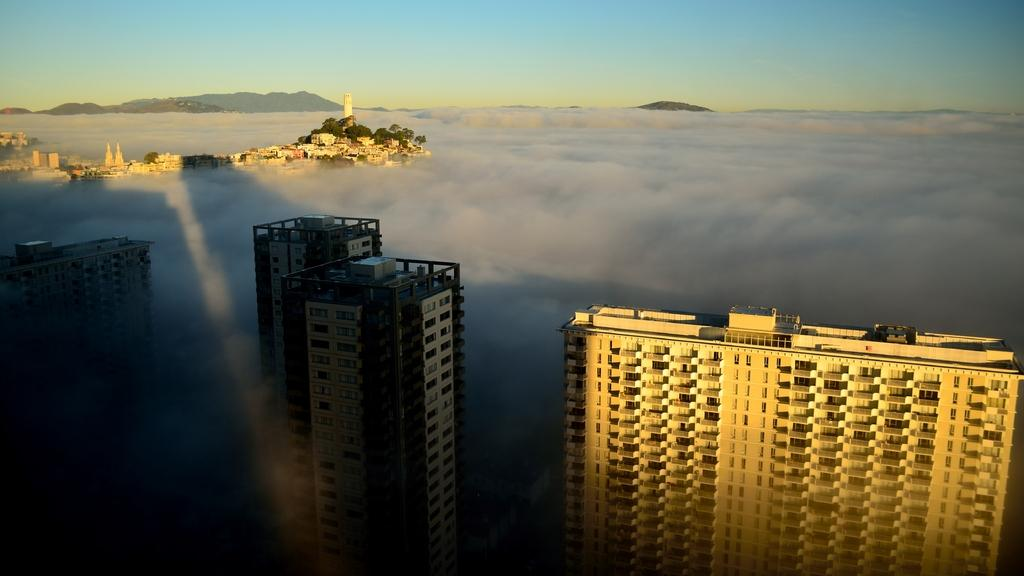What type of structures can be seen in the image? There are buildings in the image. What other natural elements are present in the image? There are trees in the image. What can be seen in the distance in the image? There are hills visible in the background of the image. What is visible at the top of the image? The sky is visible at the top of the image. What type of amusement can be seen in the image? There is no amusement park or ride present in the image; it features buildings, trees, hills, and the sky. Can you tell me how many times the story is mentioned in the image? There is no story or narrative present in the image; it is a visual representation of buildings, trees, hills, and the sky. 